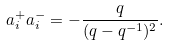<formula> <loc_0><loc_0><loc_500><loc_500>a _ { i } ^ { + } a _ { i } ^ { - } = - \frac { q } { ( q - q ^ { - 1 } ) ^ { 2 } } .</formula> 